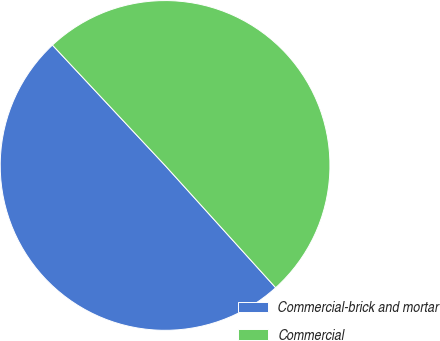Convert chart. <chart><loc_0><loc_0><loc_500><loc_500><pie_chart><fcel>Commercial-brick and mortar<fcel>Commercial<nl><fcel>49.73%<fcel>50.27%<nl></chart> 